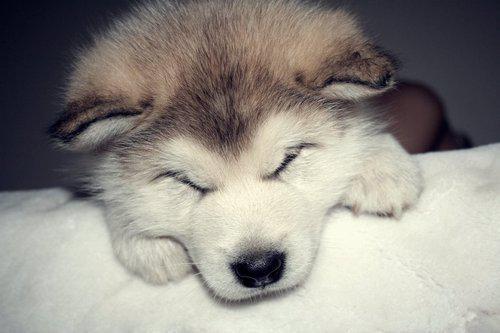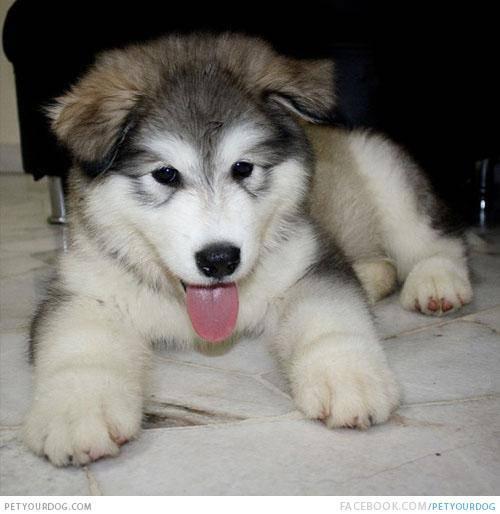The first image is the image on the left, the second image is the image on the right. Given the left and right images, does the statement "There are two Huskies in one image and a single Husky in another image." hold true? Answer yes or no. No. The first image is the image on the left, the second image is the image on the right. Evaluate the accuracy of this statement regarding the images: "The left image contains two side-by-side puppies who are facing forward and sitting upright.". Is it true? Answer yes or no. No. 